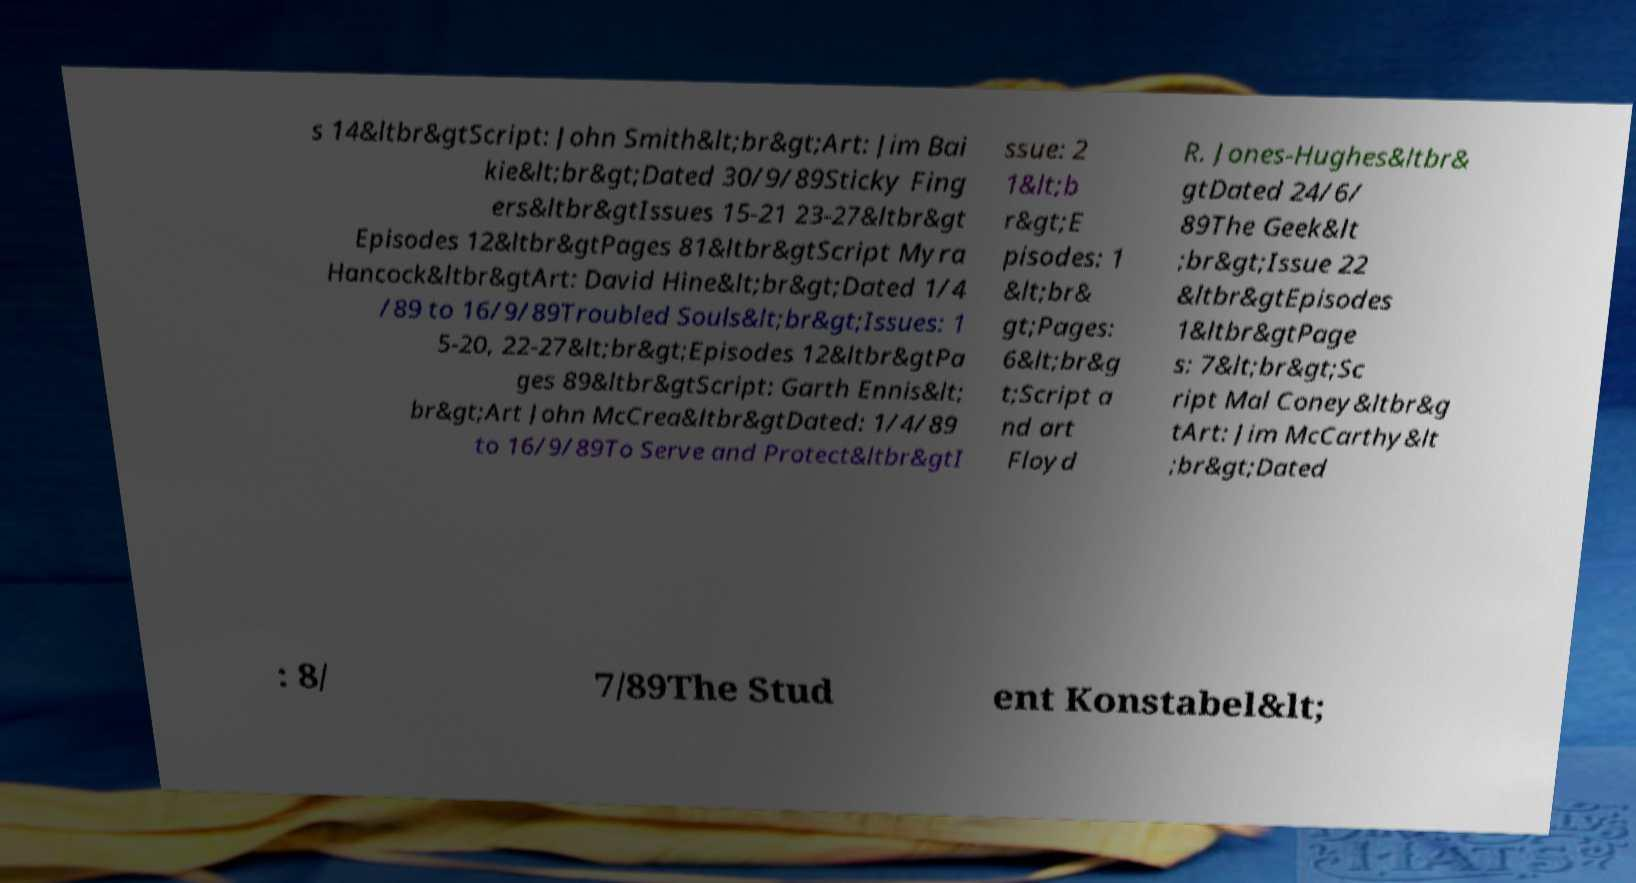Can you accurately transcribe the text from the provided image for me? s 14&ltbr&gtScript: John Smith&lt;br&gt;Art: Jim Bai kie&lt;br&gt;Dated 30/9/89Sticky Fing ers&ltbr&gtIssues 15-21 23-27&ltbr&gt Episodes 12&ltbr&gtPages 81&ltbr&gtScript Myra Hancock&ltbr&gtArt: David Hine&lt;br&gt;Dated 1/4 /89 to 16/9/89Troubled Souls&lt;br&gt;Issues: 1 5-20, 22-27&lt;br&gt;Episodes 12&ltbr&gtPa ges 89&ltbr&gtScript: Garth Ennis&lt; br&gt;Art John McCrea&ltbr&gtDated: 1/4/89 to 16/9/89To Serve and Protect&ltbr&gtI ssue: 2 1&lt;b r&gt;E pisodes: 1 &lt;br& gt;Pages: 6&lt;br&g t;Script a nd art Floyd R. Jones-Hughes&ltbr& gtDated 24/6/ 89The Geek&lt ;br&gt;Issue 22 &ltbr&gtEpisodes 1&ltbr&gtPage s: 7&lt;br&gt;Sc ript Mal Coney&ltbr&g tArt: Jim McCarthy&lt ;br&gt;Dated : 8/ 7/89The Stud ent Konstabel&lt; 